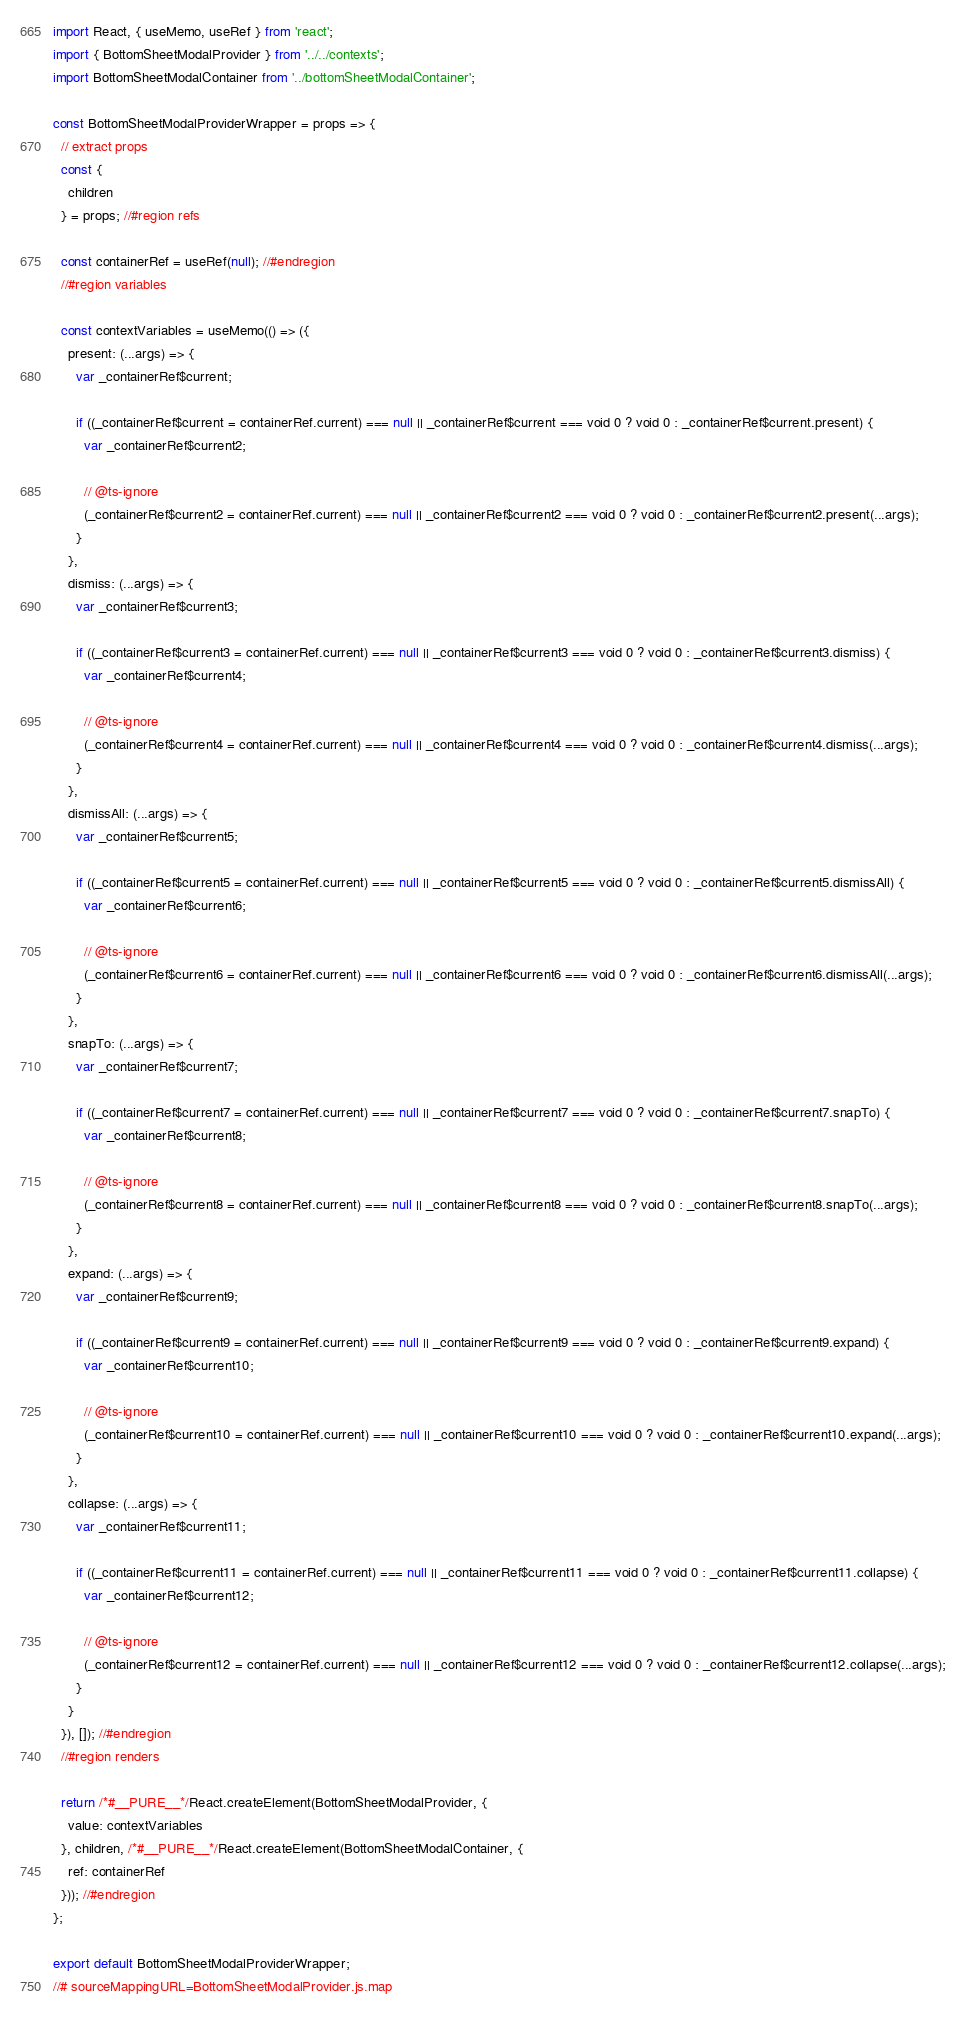Convert code to text. <code><loc_0><loc_0><loc_500><loc_500><_JavaScript_>import React, { useMemo, useRef } from 'react';
import { BottomSheetModalProvider } from '../../contexts';
import BottomSheetModalContainer from '../bottomSheetModalContainer';

const BottomSheetModalProviderWrapper = props => {
  // extract props
  const {
    children
  } = props; //#region refs

  const containerRef = useRef(null); //#endregion
  //#region variables

  const contextVariables = useMemo(() => ({
    present: (...args) => {
      var _containerRef$current;

      if ((_containerRef$current = containerRef.current) === null || _containerRef$current === void 0 ? void 0 : _containerRef$current.present) {
        var _containerRef$current2;

        // @ts-ignore
        (_containerRef$current2 = containerRef.current) === null || _containerRef$current2 === void 0 ? void 0 : _containerRef$current2.present(...args);
      }
    },
    dismiss: (...args) => {
      var _containerRef$current3;

      if ((_containerRef$current3 = containerRef.current) === null || _containerRef$current3 === void 0 ? void 0 : _containerRef$current3.dismiss) {
        var _containerRef$current4;

        // @ts-ignore
        (_containerRef$current4 = containerRef.current) === null || _containerRef$current4 === void 0 ? void 0 : _containerRef$current4.dismiss(...args);
      }
    },
    dismissAll: (...args) => {
      var _containerRef$current5;

      if ((_containerRef$current5 = containerRef.current) === null || _containerRef$current5 === void 0 ? void 0 : _containerRef$current5.dismissAll) {
        var _containerRef$current6;

        // @ts-ignore
        (_containerRef$current6 = containerRef.current) === null || _containerRef$current6 === void 0 ? void 0 : _containerRef$current6.dismissAll(...args);
      }
    },
    snapTo: (...args) => {
      var _containerRef$current7;

      if ((_containerRef$current7 = containerRef.current) === null || _containerRef$current7 === void 0 ? void 0 : _containerRef$current7.snapTo) {
        var _containerRef$current8;

        // @ts-ignore
        (_containerRef$current8 = containerRef.current) === null || _containerRef$current8 === void 0 ? void 0 : _containerRef$current8.snapTo(...args);
      }
    },
    expand: (...args) => {
      var _containerRef$current9;

      if ((_containerRef$current9 = containerRef.current) === null || _containerRef$current9 === void 0 ? void 0 : _containerRef$current9.expand) {
        var _containerRef$current10;

        // @ts-ignore
        (_containerRef$current10 = containerRef.current) === null || _containerRef$current10 === void 0 ? void 0 : _containerRef$current10.expand(...args);
      }
    },
    collapse: (...args) => {
      var _containerRef$current11;

      if ((_containerRef$current11 = containerRef.current) === null || _containerRef$current11 === void 0 ? void 0 : _containerRef$current11.collapse) {
        var _containerRef$current12;

        // @ts-ignore
        (_containerRef$current12 = containerRef.current) === null || _containerRef$current12 === void 0 ? void 0 : _containerRef$current12.collapse(...args);
      }
    }
  }), []); //#endregion
  //#region renders

  return /*#__PURE__*/React.createElement(BottomSheetModalProvider, {
    value: contextVariables
  }, children, /*#__PURE__*/React.createElement(BottomSheetModalContainer, {
    ref: containerRef
  })); //#endregion
};

export default BottomSheetModalProviderWrapper;
//# sourceMappingURL=BottomSheetModalProvider.js.map</code> 